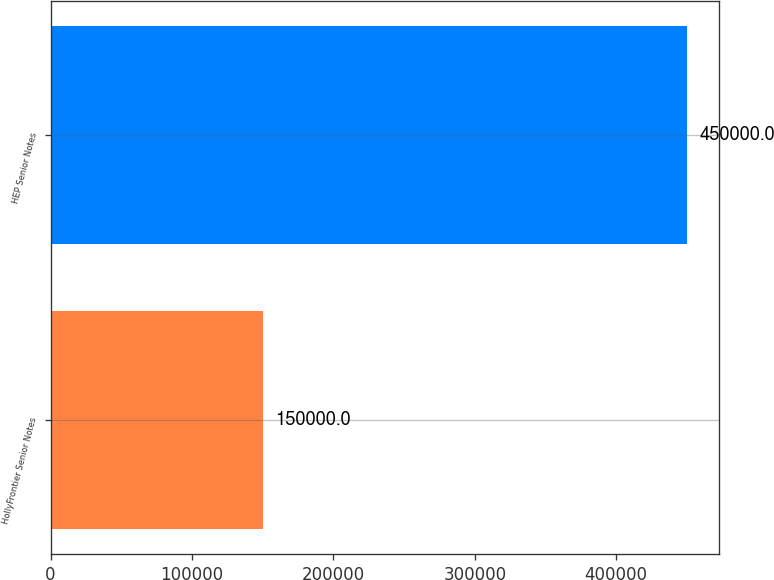Convert chart. <chart><loc_0><loc_0><loc_500><loc_500><bar_chart><fcel>HollyFrontier Senior Notes<fcel>HEP Senior Notes<nl><fcel>150000<fcel>450000<nl></chart> 